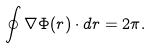<formula> <loc_0><loc_0><loc_500><loc_500>\oint \nabla \Phi ( r ) \cdot d r = 2 \pi .</formula> 